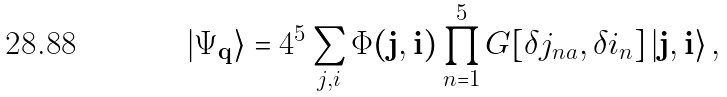<formula> <loc_0><loc_0><loc_500><loc_500>\left | \Psi _ { \mathbf q } \right \rangle = 4 ^ { 5 } \sum _ { j , i } \Phi ( { \mathbf j } , { \mathbf i } ) \prod _ { n = 1 } ^ { 5 } G [ \delta j _ { n a } , \delta i _ { n } ] \left | \mathbf j , \mathbf i \right \rangle ,</formula> 